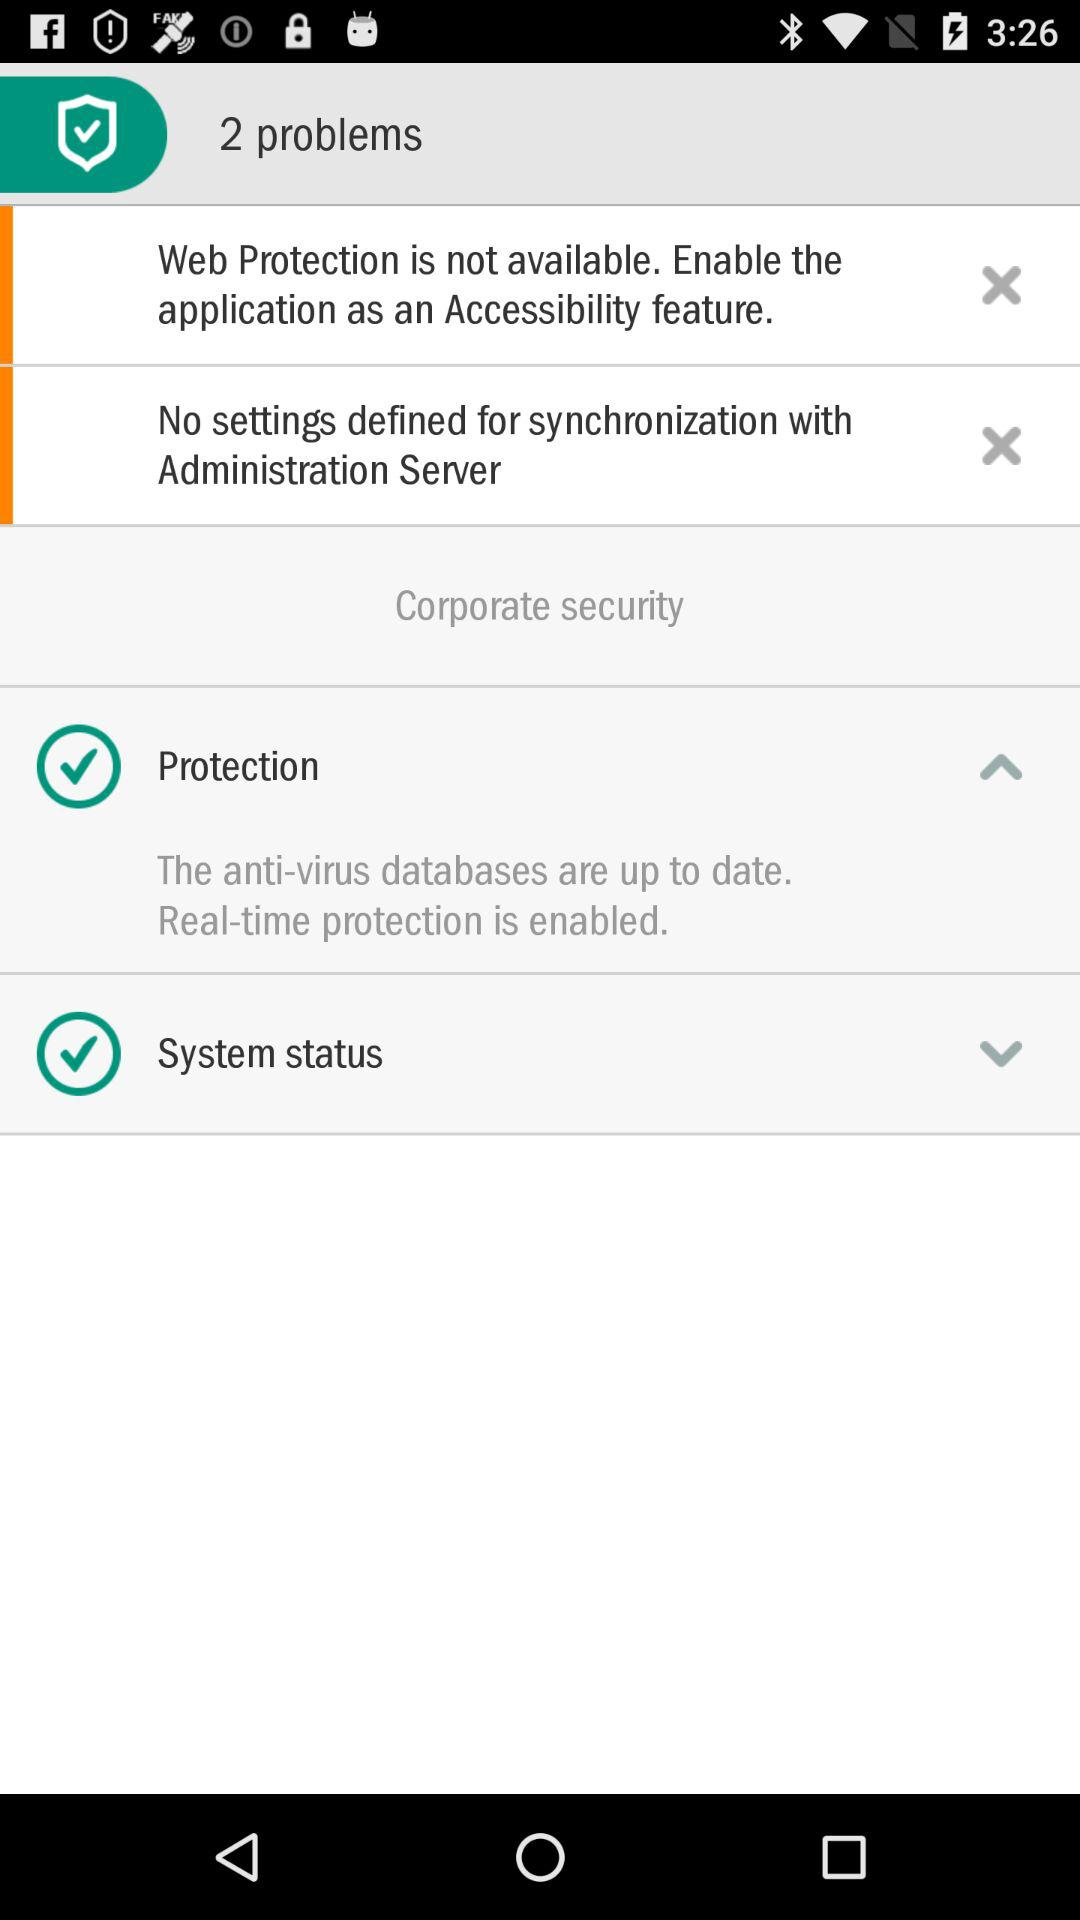How many problems are shown here? There are 2 problems shown. 